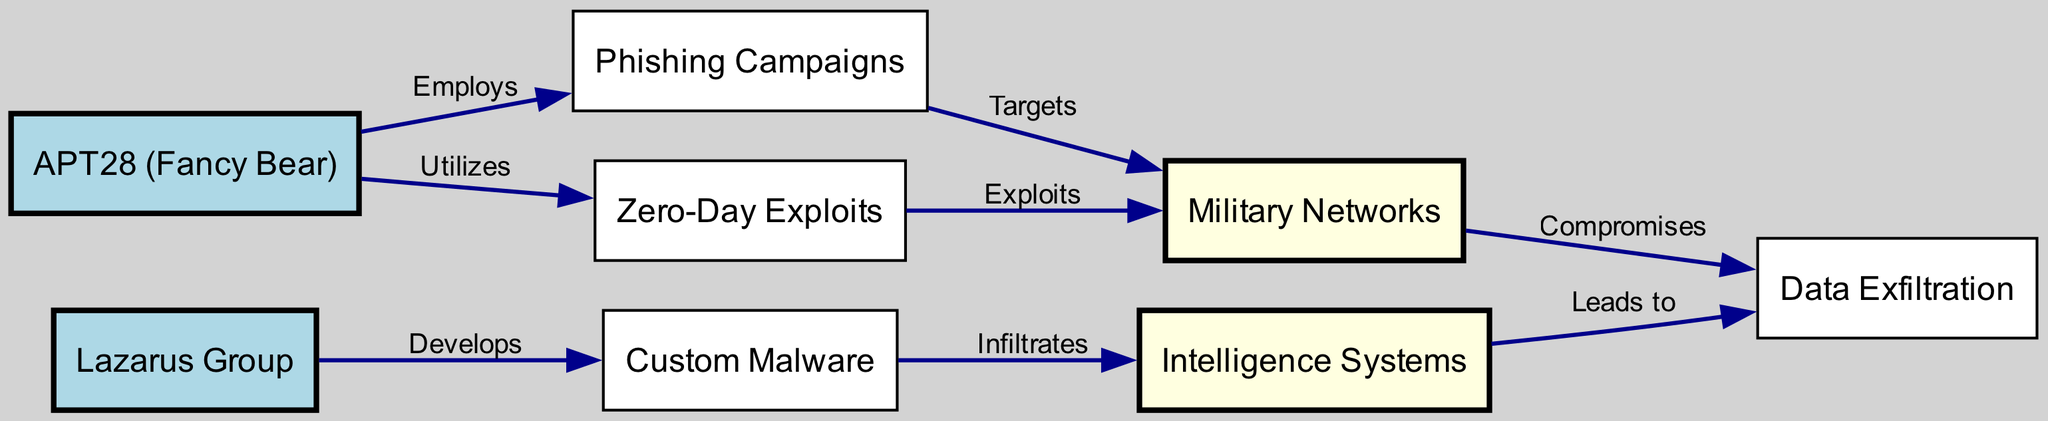What is the total number of nodes in the diagram? There are 8 nodes listed in the data: APT28, Lazarus, Phishing, Malware, ZeroDay, MilNetwork, IntSystems, and DataExfil.
Answer: 8 Which group employs phishing campaigns? The edge from APT28 to Phishing indicates that APT28 is the group that employs phishing campaigns, as it is the source node pointing to Phishing.
Answer: APT28 How many attack vectors are utilized by APT28? APT28 has two attack vectors connected to it: Phishing and Zero-Day exploits, as there are edges from APT28 to both nodes.
Answer: 2 What does Malware infiltrate? The edge from Malware to Intelligence Systems shows that Malware infiltrates Intelligence Systems.
Answer: Intelligence Systems What are the target systems of phishing campaigns? The edge from Phishing to Military Networks indicates that phishing campaigns target Military Networks.
Answer: Military Networks Which node leads to data exfiltration? The edge from Intelligence Systems to Data Exfiltration indicates that it leads to data exfiltration, as it is the source node for this edge.
Answer: Intelligence Systems How many edges originate from the node labeled Zero-Day? There is one outgoing edge from Zero-Day to MilNetwork, which indicates it exploits this target, making the total one edge.
Answer: 1 Which nodes are involved in exploiting military networks? Both Zero-Day and Phishing target Military Networks, as indicated by the edges stemming from both nodes to MilNetwork.
Answer: Zero-Day and Phishing What is the relationship between MilNetwork and Data Exfiltration? There are two edges connecting MilNetwork to Data Exfiltration; one indicates it compromises data and the other shows that it leads to data exfiltration.
Answer: Compromises and Leads to 